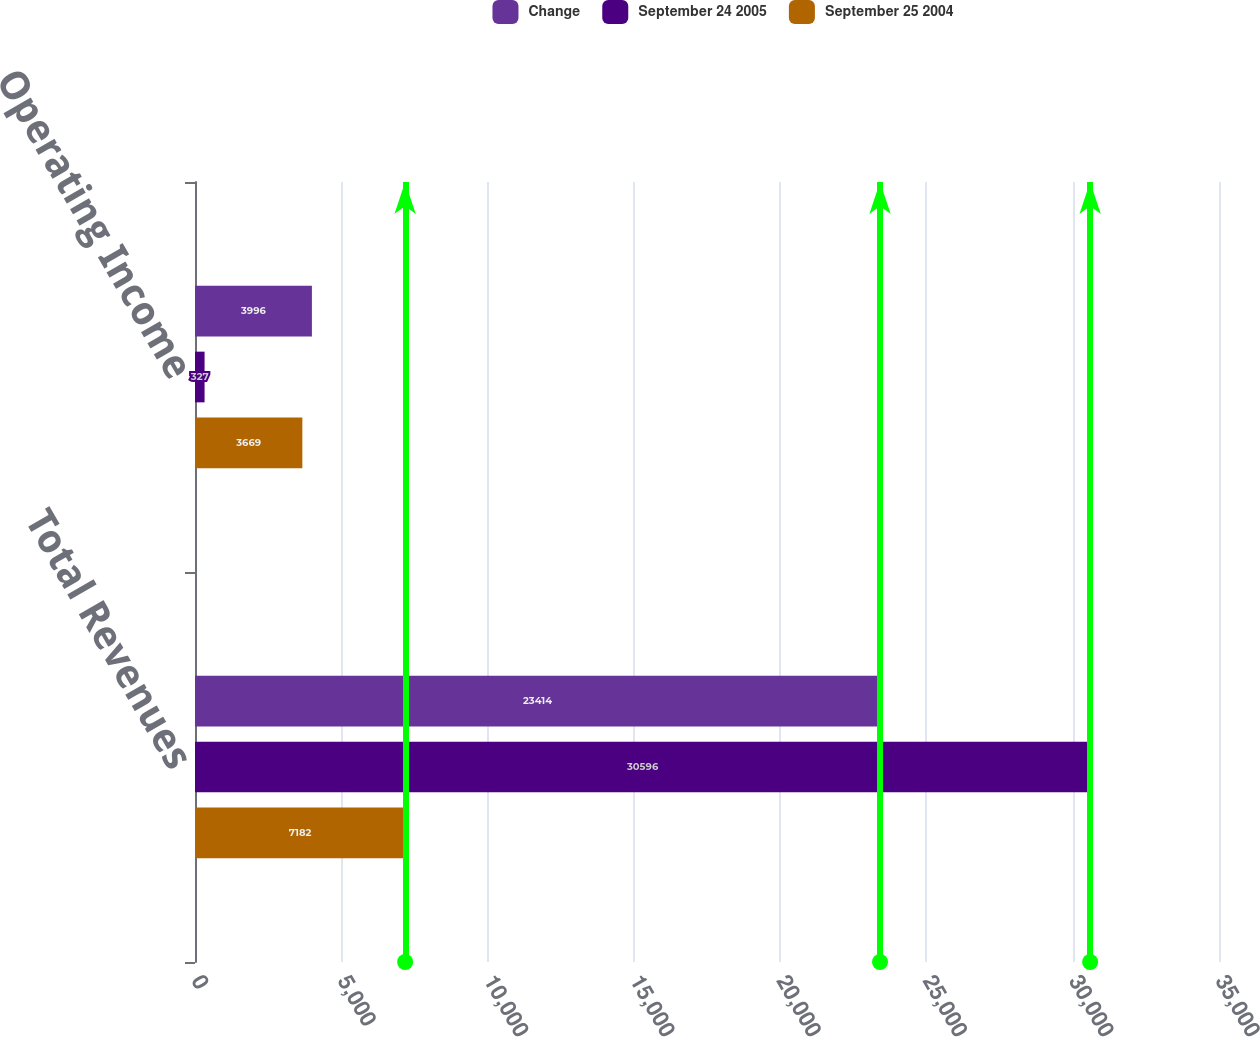Convert chart to OTSL. <chart><loc_0><loc_0><loc_500><loc_500><stacked_bar_chart><ecel><fcel>Total Revenues<fcel>Operating Income<nl><fcel>Change<fcel>23414<fcel>3996<nl><fcel>September 24 2005<fcel>30596<fcel>327<nl><fcel>September 25 2004<fcel>7182<fcel>3669<nl></chart> 